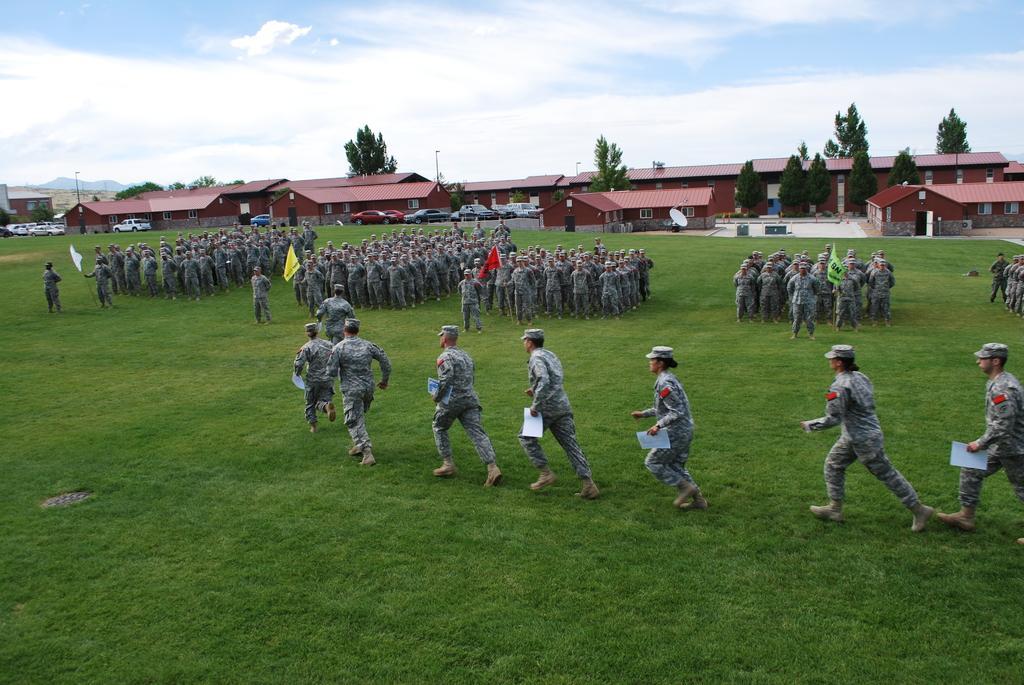Could you give a brief overview of what you see in this image? In this image we can see a group of people standing on the grass field. In that some are holding the papers and the flags. On the backside we can see a group of houses with roof and windows, some cars, a dish, a group of trees, poles, the hills and the sky which looks cloudy. 